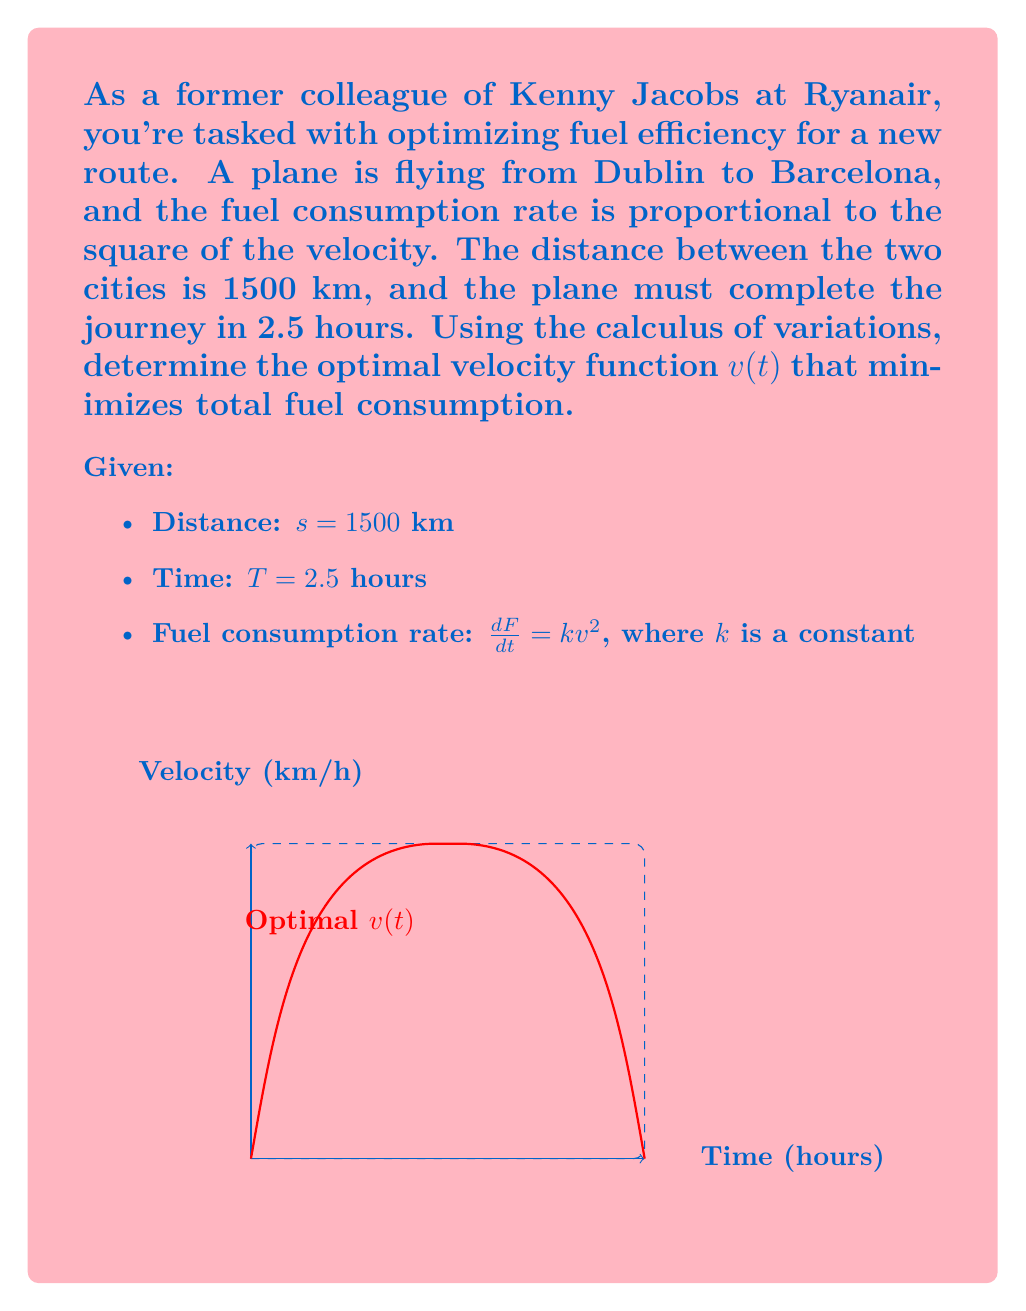Show me your answer to this math problem. Let's approach this problem step-by-step using the calculus of variations:

1) The functional to be minimized is the total fuel consumption:
   $$J = \int_0^T kv^2 dt$$

2) We have the constraint that the total distance traveled must equal 1500 km:
   $$\int_0^T v dt = 1500$$

3) We form the augmented functional with a Lagrange multiplier $\lambda$:
   $$J^* = \int_0^T (kv^2 + \lambda v) dt$$

4) The Euler-Lagrange equation for this problem is:
   $$\frac{\partial}{\partial v}(kv^2 + \lambda v) - \frac{d}{dt}\frac{\partial}{\partial v'}(kv^2 + \lambda v) = 0$$

5) Simplifying:
   $$2kv + \lambda = 0$$

6) Solving for v:
   $$v = -\frac{\lambda}{2k}$$

7) This shows that the optimal velocity is constant throughout the flight.

8) Using the constraint equation:
   $$\int_0^{2.5} v dt = 1500$$
   $$2.5v = 1500$$
   $$v = 600 \text{ km/h}$$

9) The constant $\lambda$ can be found:
   $$\lambda = -2kv = -1200k$$

Thus, the optimal velocity function is a constant $v(t) = 600$ km/h.
Answer: $v(t) = 600$ km/h 